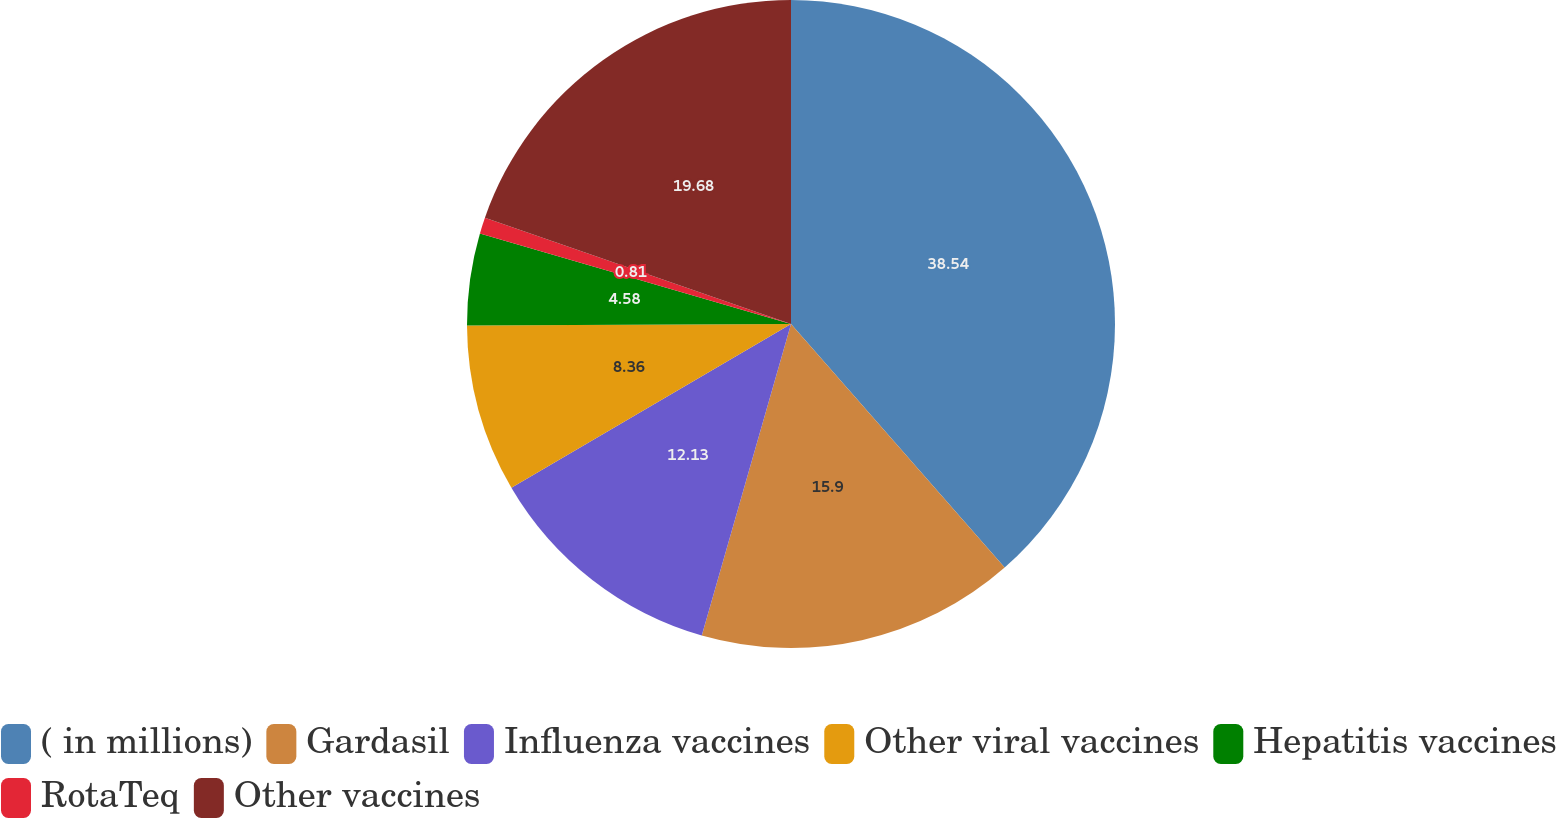Convert chart. <chart><loc_0><loc_0><loc_500><loc_500><pie_chart><fcel>( in millions)<fcel>Gardasil<fcel>Influenza vaccines<fcel>Other viral vaccines<fcel>Hepatitis vaccines<fcel>RotaTeq<fcel>Other vaccines<nl><fcel>38.54%<fcel>15.9%<fcel>12.13%<fcel>8.36%<fcel>4.58%<fcel>0.81%<fcel>19.68%<nl></chart> 